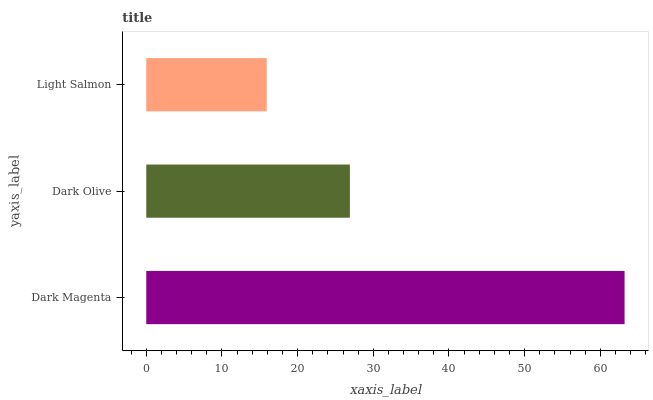Is Light Salmon the minimum?
Answer yes or no. Yes. Is Dark Magenta the maximum?
Answer yes or no. Yes. Is Dark Olive the minimum?
Answer yes or no. No. Is Dark Olive the maximum?
Answer yes or no. No. Is Dark Magenta greater than Dark Olive?
Answer yes or no. Yes. Is Dark Olive less than Dark Magenta?
Answer yes or no. Yes. Is Dark Olive greater than Dark Magenta?
Answer yes or no. No. Is Dark Magenta less than Dark Olive?
Answer yes or no. No. Is Dark Olive the high median?
Answer yes or no. Yes. Is Dark Olive the low median?
Answer yes or no. Yes. Is Light Salmon the high median?
Answer yes or no. No. Is Light Salmon the low median?
Answer yes or no. No. 